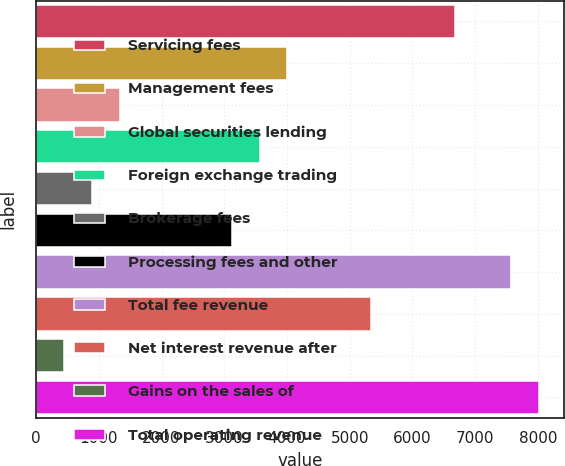Convert chart. <chart><loc_0><loc_0><loc_500><loc_500><bar_chart><fcel>Servicing fees<fcel>Management fees<fcel>Global securities lending<fcel>Foreign exchange trading<fcel>Brokerage fees<fcel>Processing fees and other<fcel>Total fee revenue<fcel>Net interest revenue after<fcel>Gains on the sales of<fcel>Total operating revenue<nl><fcel>6678.38<fcel>4007.96<fcel>1337.54<fcel>3562.89<fcel>892.47<fcel>3117.82<fcel>7568.52<fcel>5343.17<fcel>447.4<fcel>8013.59<nl></chart> 